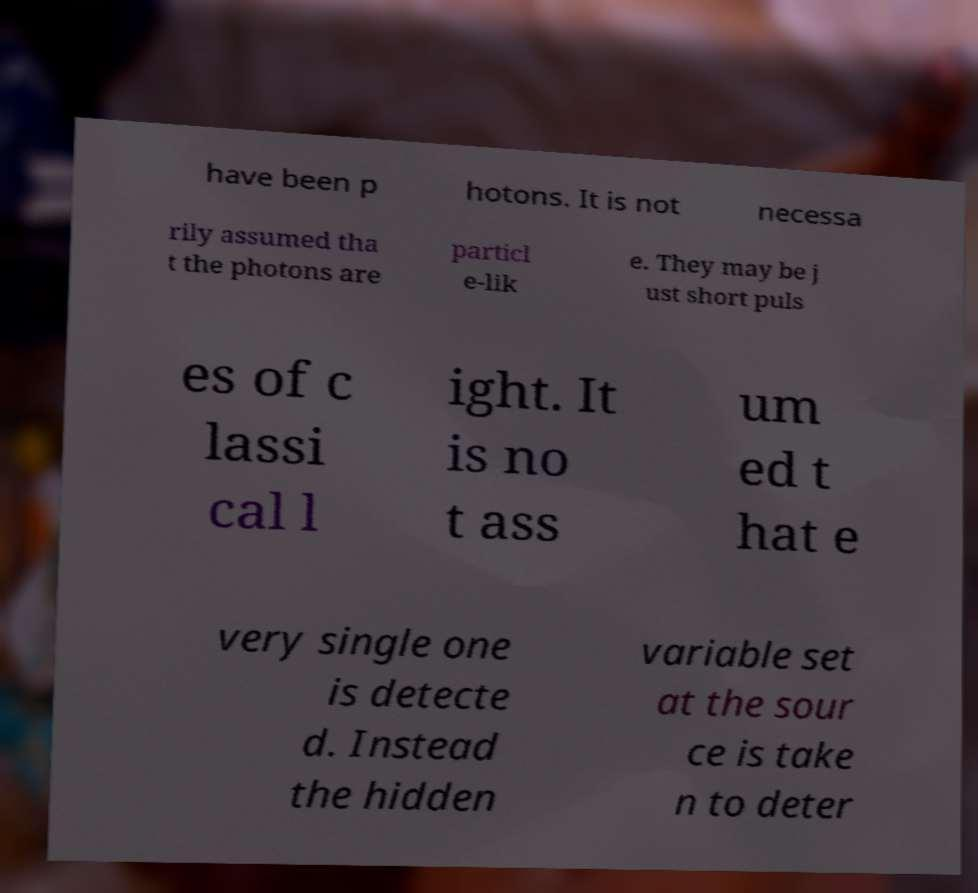Could you assist in decoding the text presented in this image and type it out clearly? have been p hotons. It is not necessa rily assumed tha t the photons are particl e-lik e. They may be j ust short puls es of c lassi cal l ight. It is no t ass um ed t hat e very single one is detecte d. Instead the hidden variable set at the sour ce is take n to deter 